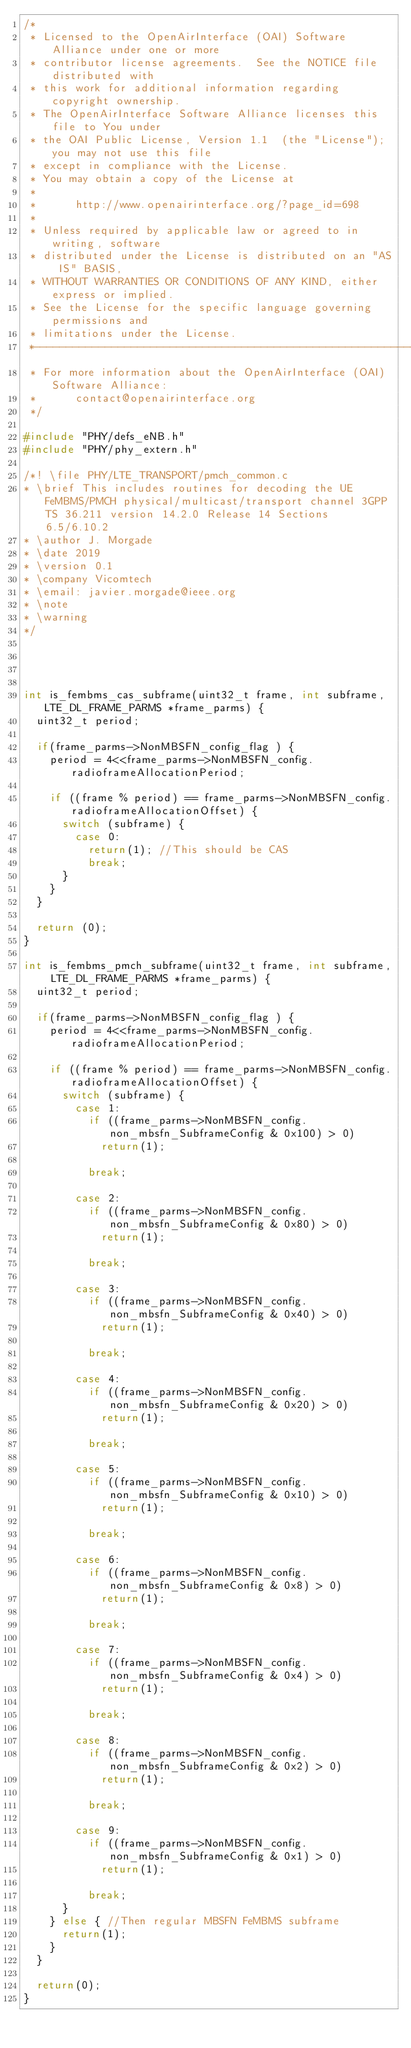Convert code to text. <code><loc_0><loc_0><loc_500><loc_500><_C_>/*
 * Licensed to the OpenAirInterface (OAI) Software Alliance under one or more
 * contributor license agreements.  See the NOTICE file distributed with
 * this work for additional information regarding copyright ownership.
 * The OpenAirInterface Software Alliance licenses this file to You under
 * the OAI Public License, Version 1.1  (the "License"); you may not use this file
 * except in compliance with the License.
 * You may obtain a copy of the License at
 *
 *      http://www.openairinterface.org/?page_id=698
 *
 * Unless required by applicable law or agreed to in writing, software
 * distributed under the License is distributed on an "AS IS" BASIS,
 * WITHOUT WARRANTIES OR CONDITIONS OF ANY KIND, either express or implied.
 * See the License for the specific language governing permissions and
 * limitations under the License.
 *-------------------------------------------------------------------------------
 * For more information about the OpenAirInterface (OAI) Software Alliance:
 *      contact@openairinterface.org
 */

#include "PHY/defs_eNB.h"
#include "PHY/phy_extern.h"

/*! \file PHY/LTE_TRANSPORT/pmch_common.c
* \brief This includes routines for decoding the UE FeMBMS/PMCH physical/multicast/transport channel 3GPP TS 36.211 version 14.2.0 Release 14 Sections 6.5/6.10.2
* \author J. Morgade
* \date 2019
* \version 0.1
* \company Vicomtech
* \email: javier.morgade@ieee.org
* \note
* \warning
*/




int is_fembms_cas_subframe(uint32_t frame, int subframe, LTE_DL_FRAME_PARMS *frame_parms) {
  uint32_t period;

  if(frame_parms->NonMBSFN_config_flag ) {
    period = 4<<frame_parms->NonMBSFN_config.radioframeAllocationPeriod;

    if ((frame % period) == frame_parms->NonMBSFN_config.radioframeAllocationOffset) {
      switch (subframe) {
        case 0:
          return(1); //This should be CAS
          break;
      }
    }
  }

  return (0);
}

int is_fembms_pmch_subframe(uint32_t frame, int subframe, LTE_DL_FRAME_PARMS *frame_parms) {
  uint32_t period;

  if(frame_parms->NonMBSFN_config_flag ) {
    period = 4<<frame_parms->NonMBSFN_config.radioframeAllocationPeriod;

    if ((frame % period) == frame_parms->NonMBSFN_config.radioframeAllocationOffset) {
      switch (subframe) {
        case 1:
          if ((frame_parms->NonMBSFN_config.non_mbsfn_SubframeConfig & 0x100) > 0)
            return(1);

          break;

        case 2:
          if ((frame_parms->NonMBSFN_config.non_mbsfn_SubframeConfig & 0x80) > 0)
            return(1);

          break;

        case 3:
          if ((frame_parms->NonMBSFN_config.non_mbsfn_SubframeConfig & 0x40) > 0)
            return(1);

          break;

        case 4:
          if ((frame_parms->NonMBSFN_config.non_mbsfn_SubframeConfig & 0x20) > 0)
            return(1);

          break;

        case 5:
          if ((frame_parms->NonMBSFN_config.non_mbsfn_SubframeConfig & 0x10) > 0)
            return(1);

          break;

        case 6:
          if ((frame_parms->NonMBSFN_config.non_mbsfn_SubframeConfig & 0x8) > 0)
            return(1);

          break;

        case 7:
          if ((frame_parms->NonMBSFN_config.non_mbsfn_SubframeConfig & 0x4) > 0)
            return(1);

          break;

        case 8:
          if ((frame_parms->NonMBSFN_config.non_mbsfn_SubframeConfig & 0x2) > 0)
            return(1);

          break;

        case 9:
          if ((frame_parms->NonMBSFN_config.non_mbsfn_SubframeConfig & 0x1) > 0)
            return(1);

          break;
      }
    } else { //Then regular MBSFN FeMBMS subframe
      return(1);
    }
  }

  return(0);
}

</code> 